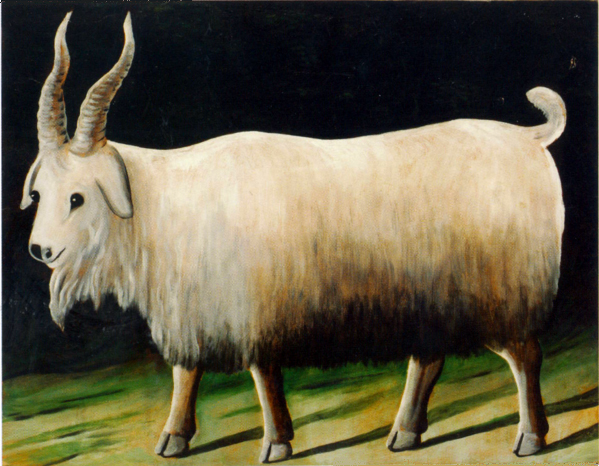Can you discuss the significance of the background in relation to the goat? The stark, dark background in this painting serves to foreground the goat, highlighting its white fur and distinctive presence. The contrast enhances the visual separation between the subject and its surroundings, focusing all attention on the goat. Additionally, the minimalistic nature of the background may suggest a timeless quality, placing the emphasis entirely on the animal's portrayal and unspecific to any particular setting or context. 